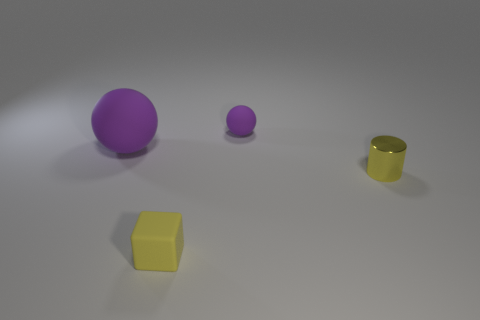Are there any other things that are the same material as the tiny yellow cube? Yes, the golden cylinder appears to be made of the same glossy material as the tiny yellow cube. Both show similar light reflections and surface qualities that suggest they could be composed of the same or similar types of materials. 